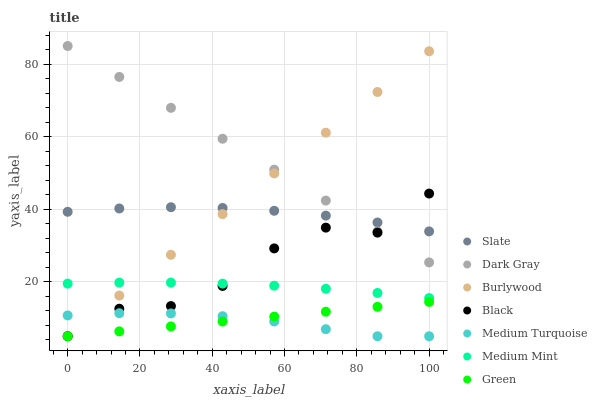Does Medium Turquoise have the minimum area under the curve?
Answer yes or no. Yes. Does Dark Gray have the maximum area under the curve?
Answer yes or no. Yes. Does Burlywood have the minimum area under the curve?
Answer yes or no. No. Does Burlywood have the maximum area under the curve?
Answer yes or no. No. Is Green the smoothest?
Answer yes or no. Yes. Is Black the roughest?
Answer yes or no. Yes. Is Burlywood the smoothest?
Answer yes or no. No. Is Burlywood the roughest?
Answer yes or no. No. Does Burlywood have the lowest value?
Answer yes or no. Yes. Does Slate have the lowest value?
Answer yes or no. No. Does Dark Gray have the highest value?
Answer yes or no. Yes. Does Burlywood have the highest value?
Answer yes or no. No. Is Medium Turquoise less than Medium Mint?
Answer yes or no. Yes. Is Dark Gray greater than Medium Mint?
Answer yes or no. Yes. Does Burlywood intersect Black?
Answer yes or no. Yes. Is Burlywood less than Black?
Answer yes or no. No. Is Burlywood greater than Black?
Answer yes or no. No. Does Medium Turquoise intersect Medium Mint?
Answer yes or no. No. 